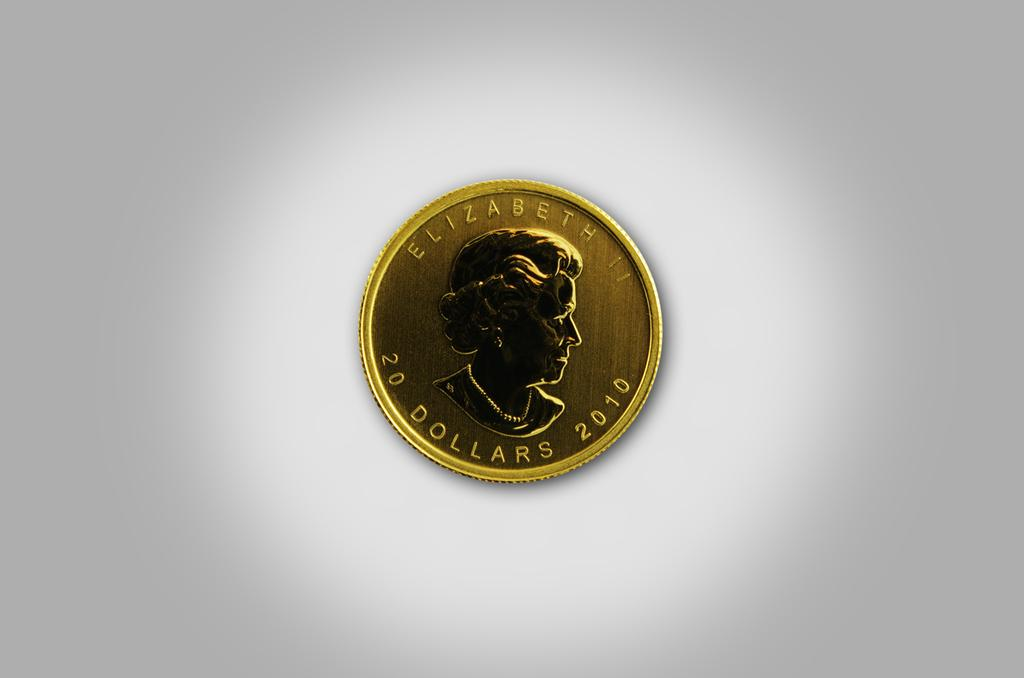<image>
Render a clear and concise summary of the photo. a gold coin that is worth 20 dollars has a lady on it 